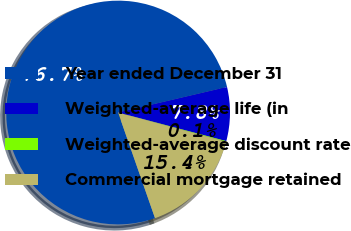Convert chart to OTSL. <chart><loc_0><loc_0><loc_500><loc_500><pie_chart><fcel>Year ended December 31<fcel>Weighted-average life (in<fcel>Weighted-average discount rate<fcel>Commercial mortgage retained<nl><fcel>76.69%<fcel>7.77%<fcel>0.11%<fcel>15.43%<nl></chart> 